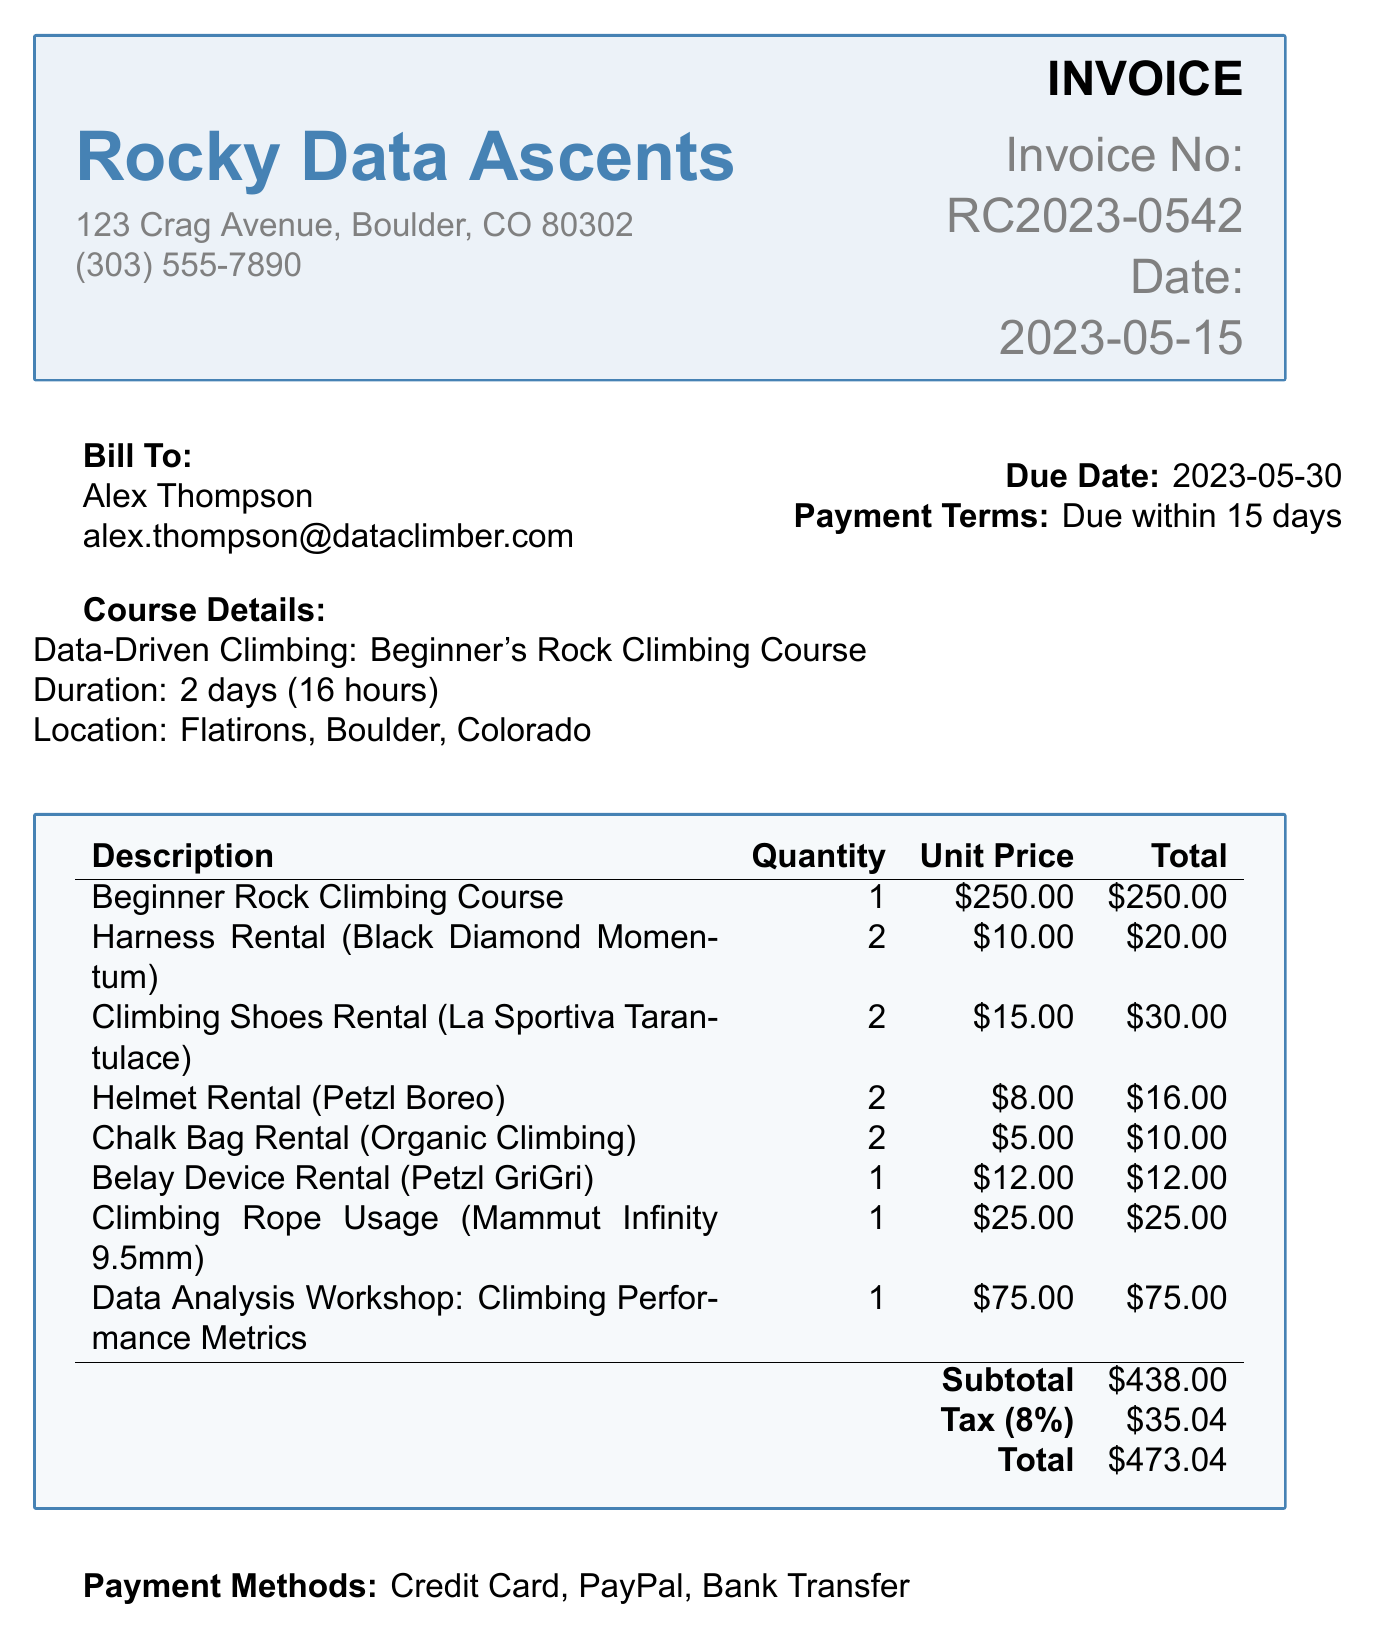What is the invoice number? The invoice number is directly specified in the document for identification.
Answer: RC2023-0542 Who is the client? The client's name is mentioned at the beginning to identify the recipient of the invoice.
Answer: Alex Thompson What is the total amount due? The total amount is calculated from the subtotal, tax, and presented at the end of the invoice.
Answer: 473.04 When is the due date? The due date is clearly stated to inform the client when payment is expected.
Answer: 2023-05-30 How many hours does the course last? The duration of the course is explicitly mentioned in the course details section.
Answer: 16 hours What is the subtotal before tax? The subtotal is provided in the breakdown of costs before applying tax.
Answer: 438.00 Which item has the highest unit price? The question requires reviewing all line items to find the highest priced item.
Answer: Beginner Rock Climbing Course What payment methods are available? Payment options are listed to inform the client how they can pay the invoice.
Answer: Credit Card, PayPal, Bank Transfer What additional resource is included with the course? The document states an additional item that participants receive upon registration.
Answer: 'Data Science for Climbers: Beginner's Guide' e-book 